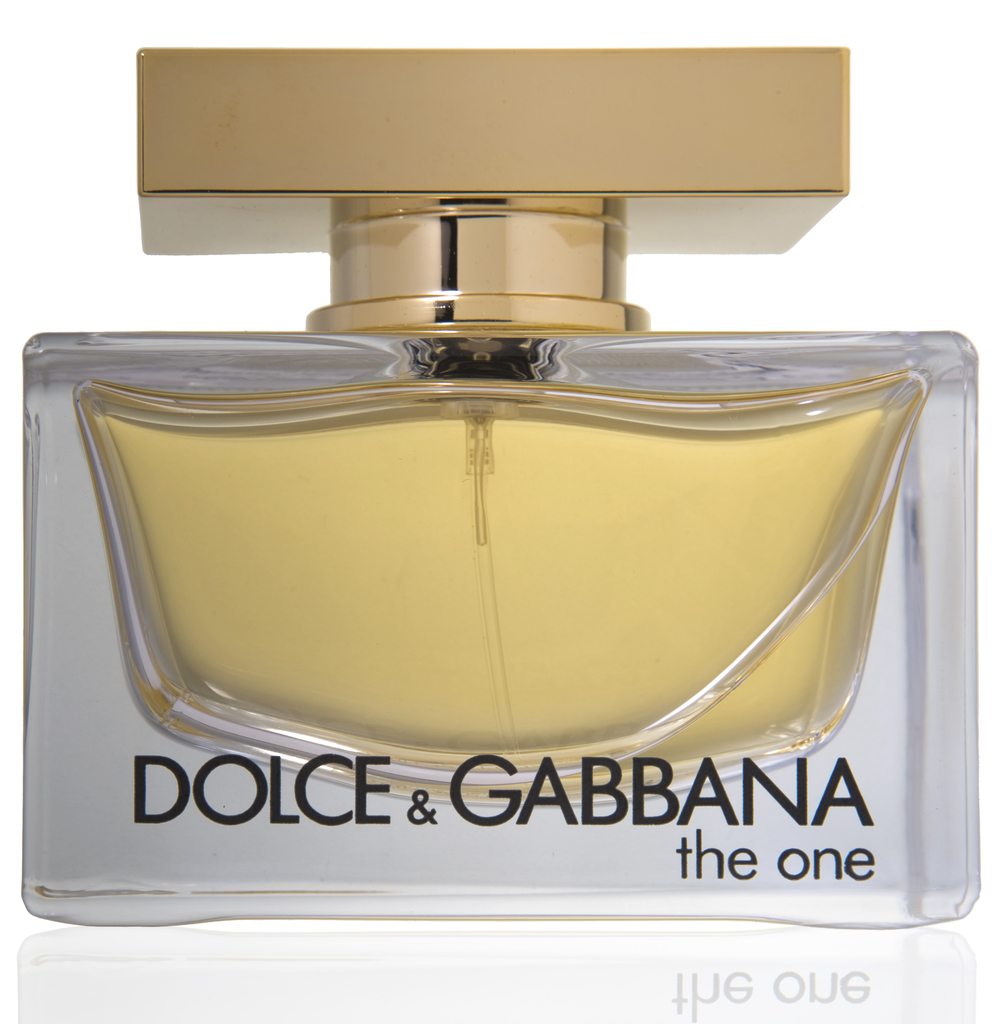Write a detailed description of the given image. The image showcases a perfume bottle from the luxury fashion house Dolce & Gabbana. The perfume is named "the one", as indicated by the text on the label. The bottle itself has a rectangular shape with a clear body that reveals the yellow perfume inside, and it is topped with a gold cap. The entire scene is set against a white background. The design of the bottle and the color of the perfume suggest a sense of elegance and luxury associated with the brand. 